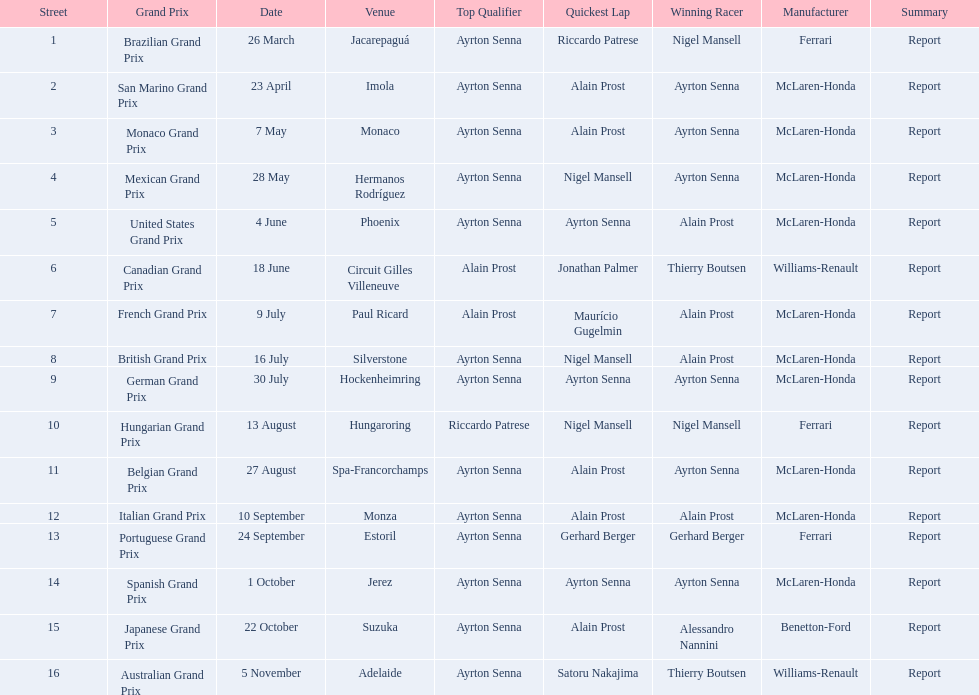How many did alain prost have the fastest lap? 5. 